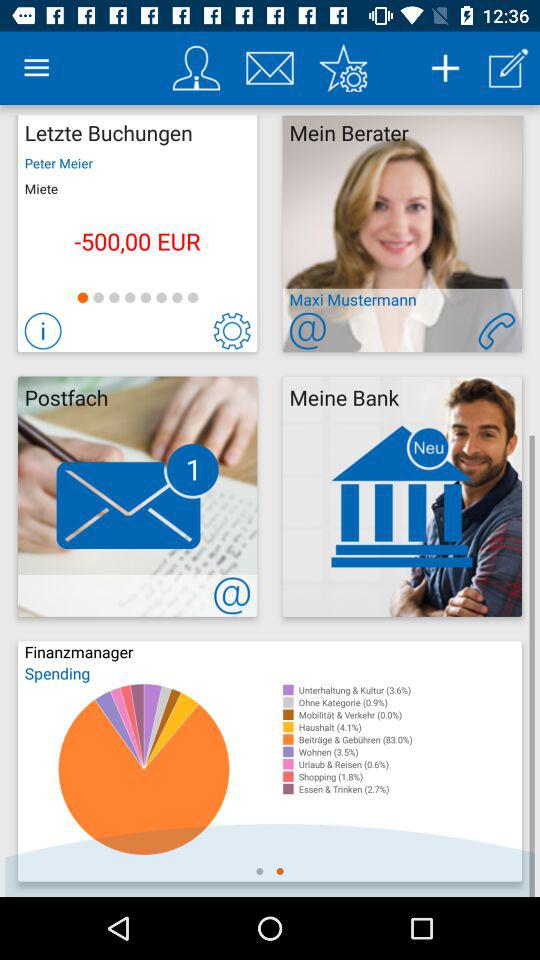Which category has the highest percentage of spending?
Answer the question using a single word or phrase. Beiträge & Gewähren 